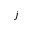<formula> <loc_0><loc_0><loc_500><loc_500>j</formula> 